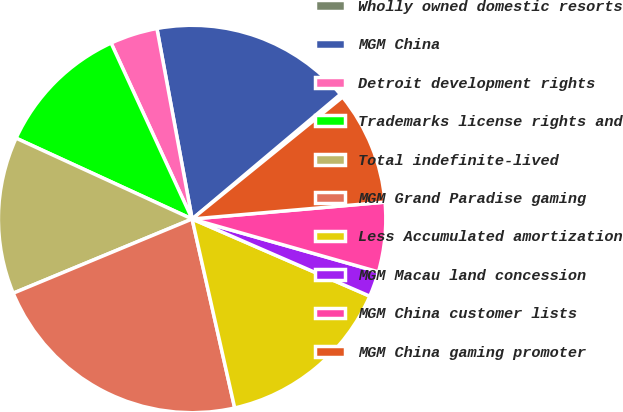Convert chart. <chart><loc_0><loc_0><loc_500><loc_500><pie_chart><fcel>Wholly owned domestic resorts<fcel>MGM China<fcel>Detroit development rights<fcel>Trademarks license rights and<fcel>Total indefinite-lived<fcel>MGM Grand Paradise gaming<fcel>Less Accumulated amortization<fcel>MGM Macau land concession<fcel>MGM China customer lists<fcel>MGM China gaming promoter<nl><fcel>0.29%<fcel>16.78%<fcel>3.96%<fcel>11.28%<fcel>13.11%<fcel>22.27%<fcel>14.95%<fcel>2.12%<fcel>5.79%<fcel>9.45%<nl></chart> 